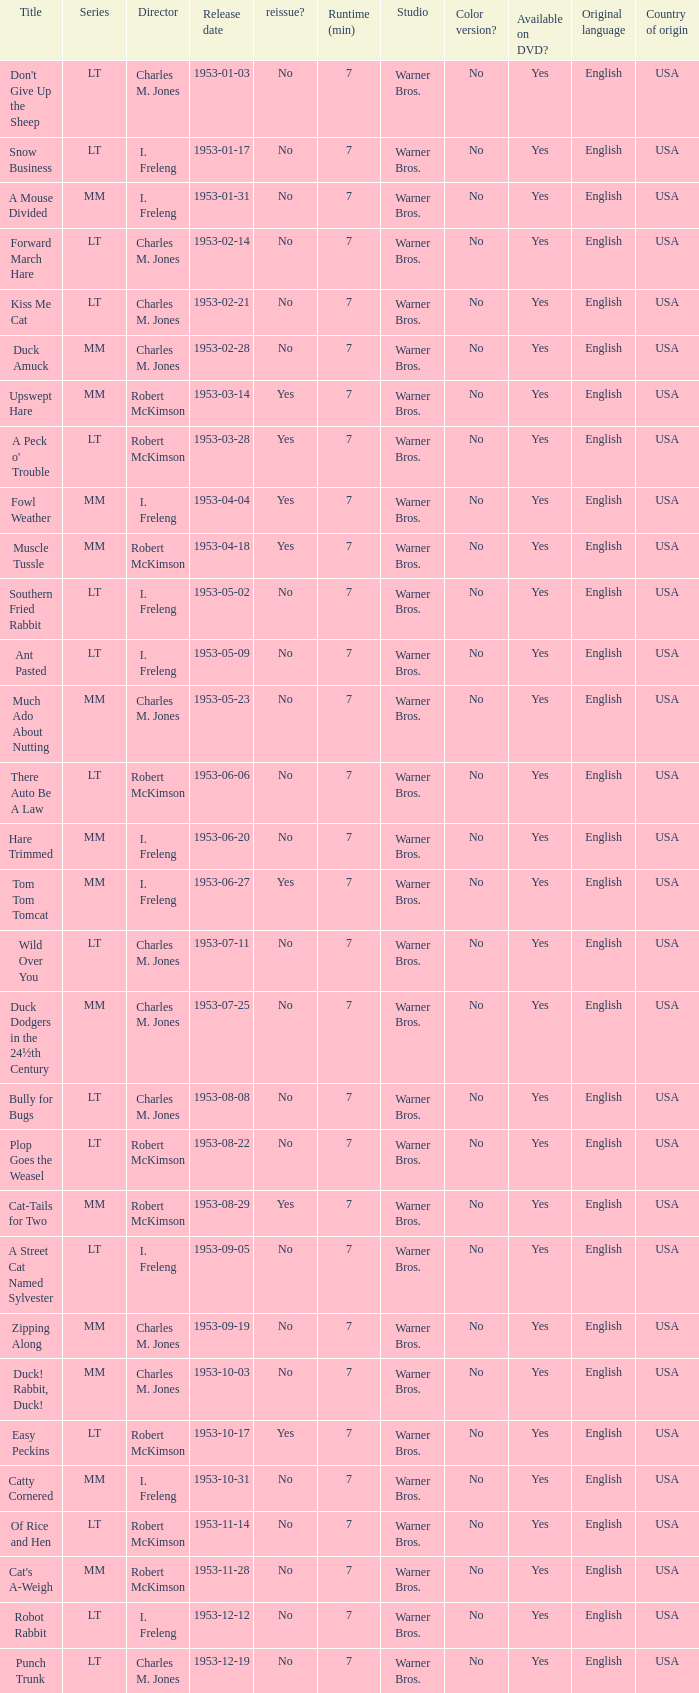Would you be able to parse every entry in this table? {'header': ['Title', 'Series', 'Director', 'Release date', 'reissue?', 'Runtime (min)', 'Studio', 'Color version?', 'Available on DVD?', 'Original language', 'Country of origin'], 'rows': [["Don't Give Up the Sheep", 'LT', 'Charles M. Jones', '1953-01-03', 'No', '7', 'Warner Bros.', 'No', 'Yes', 'English', 'USA'], ['Snow Business', 'LT', 'I. Freleng', '1953-01-17', 'No', '7', 'Warner Bros.', 'No', 'Yes', 'English', 'USA'], ['A Mouse Divided', 'MM', 'I. Freleng', '1953-01-31', 'No', '7', 'Warner Bros.', 'No', 'Yes', 'English', 'USA'], ['Forward March Hare', 'LT', 'Charles M. Jones', '1953-02-14', 'No', '7', 'Warner Bros.', 'No', 'Yes', 'English', 'USA'], ['Kiss Me Cat', 'LT', 'Charles M. Jones', '1953-02-21', 'No', '7', 'Warner Bros.', 'No', 'Yes', 'English', 'USA'], ['Duck Amuck', 'MM', 'Charles M. Jones', '1953-02-28', 'No', '7', 'Warner Bros.', 'No', 'Yes', 'English', 'USA'], ['Upswept Hare', 'MM', 'Robert McKimson', '1953-03-14', 'Yes', '7', 'Warner Bros.', 'No', 'Yes', 'English', 'USA'], ["A Peck o' Trouble", 'LT', 'Robert McKimson', '1953-03-28', 'Yes', '7', 'Warner Bros.', 'No', 'Yes', 'English', 'USA'], ['Fowl Weather', 'MM', 'I. Freleng', '1953-04-04', 'Yes', '7', 'Warner Bros.', 'No', 'Yes', 'English', 'USA'], ['Muscle Tussle', 'MM', 'Robert McKimson', '1953-04-18', 'Yes', '7', 'Warner Bros.', 'No', 'Yes', 'English', 'USA'], ['Southern Fried Rabbit', 'LT', 'I. Freleng', '1953-05-02', 'No', '7', 'Warner Bros.', 'No', 'Yes', 'English', 'USA'], ['Ant Pasted', 'LT', 'I. Freleng', '1953-05-09', 'No', '7', 'Warner Bros.', 'No', 'Yes', 'English', 'USA'], ['Much Ado About Nutting', 'MM', 'Charles M. Jones', '1953-05-23', 'No', '7', 'Warner Bros.', 'No', 'Yes', 'English', 'USA'], ['There Auto Be A Law', 'LT', 'Robert McKimson', '1953-06-06', 'No', '7', 'Warner Bros.', 'No', 'Yes', 'English', 'USA'], ['Hare Trimmed', 'MM', 'I. Freleng', '1953-06-20', 'No', '7', 'Warner Bros.', 'No', 'Yes', 'English', 'USA'], ['Tom Tom Tomcat', 'MM', 'I. Freleng', '1953-06-27', 'Yes', '7', 'Warner Bros.', 'No', 'Yes', 'English', 'USA'], ['Wild Over You', 'LT', 'Charles M. Jones', '1953-07-11', 'No', '7', 'Warner Bros.', 'No', 'Yes', 'English', 'USA'], ['Duck Dodgers in the 24½th Century', 'MM', 'Charles M. Jones', '1953-07-25', 'No', '7', 'Warner Bros.', 'No', 'Yes', 'English', 'USA'], ['Bully for Bugs', 'LT', 'Charles M. Jones', '1953-08-08', 'No', '7', 'Warner Bros.', 'No', 'Yes', 'English', 'USA'], ['Plop Goes the Weasel', 'LT', 'Robert McKimson', '1953-08-22', 'No', '7', 'Warner Bros.', 'No', 'Yes', 'English', 'USA'], ['Cat-Tails for Two', 'MM', 'Robert McKimson', '1953-08-29', 'Yes', '7', 'Warner Bros.', 'No', 'Yes', 'English', 'USA'], ['A Street Cat Named Sylvester', 'LT', 'I. Freleng', '1953-09-05', 'No', '7', 'Warner Bros.', 'No', 'Yes', 'English', 'USA'], ['Zipping Along', 'MM', 'Charles M. Jones', '1953-09-19', 'No', '7', 'Warner Bros.', 'No', 'Yes', 'English', 'USA'], ['Duck! Rabbit, Duck!', 'MM', 'Charles M. Jones', '1953-10-03', 'No', '7', 'Warner Bros.', 'No', 'Yes', 'English', 'USA'], ['Easy Peckins', 'LT', 'Robert McKimson', '1953-10-17', 'Yes', '7', 'Warner Bros.', 'No', 'Yes', 'English', 'USA'], ['Catty Cornered', 'MM', 'I. Freleng', '1953-10-31', 'No', '7', 'Warner Bros.', 'No', 'Yes', 'English', 'USA'], ['Of Rice and Hen', 'LT', 'Robert McKimson', '1953-11-14', 'No', '7', 'Warner Bros.', 'No', 'Yes', 'English', 'USA'], ["Cat's A-Weigh", 'MM', 'Robert McKimson', '1953-11-28', 'No', '7', 'Warner Bros.', 'No', 'Yes', 'English', 'USA'], ['Robot Rabbit', 'LT', 'I. Freleng', '1953-12-12', 'No', '7', 'Warner Bros.', 'No', 'Yes', 'English', 'USA'], ['Punch Trunk', 'LT', 'Charles M. Jones', '1953-12-19', 'No', '7', 'Warner Bros.', 'No', 'Yes', 'English', 'USA']]} What's the title for the release date of 1953-01-31 in the MM series, no reissue, and a director of I. Freleng? A Mouse Divided. 